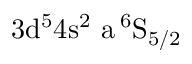Convert formula to latex. <formula><loc_0><loc_0><loc_500><loc_500>3 d ^ { 5 } 4 s ^ { 2 } \ a \, ^ { 6 } S _ { 5 / 2 }</formula> 